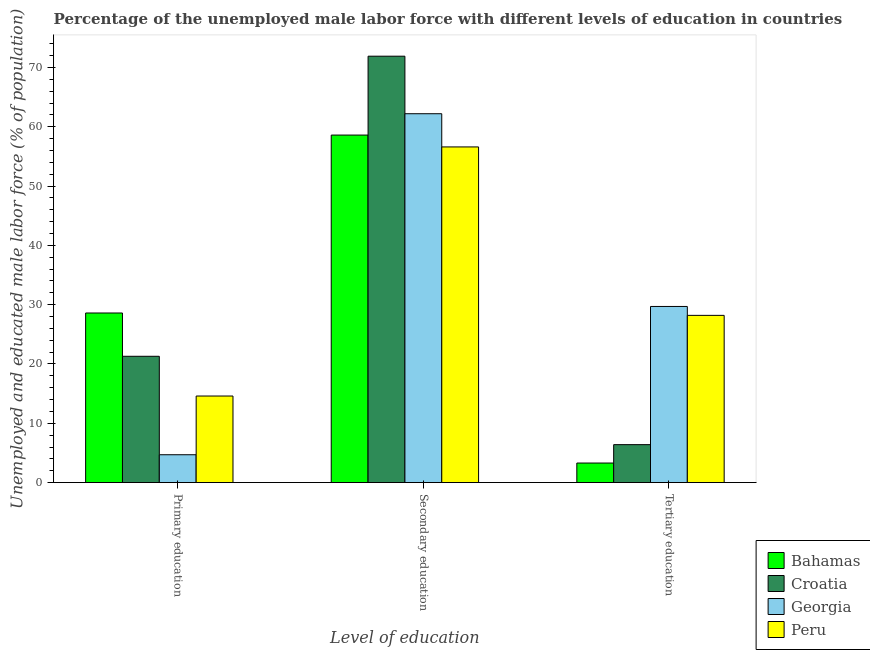How many different coloured bars are there?
Make the answer very short. 4. Are the number of bars per tick equal to the number of legend labels?
Make the answer very short. Yes. Are the number of bars on each tick of the X-axis equal?
Make the answer very short. Yes. How many bars are there on the 1st tick from the right?
Your response must be concise. 4. What is the label of the 2nd group of bars from the left?
Provide a short and direct response. Secondary education. What is the percentage of male labor force who received secondary education in Georgia?
Your answer should be compact. 62.2. Across all countries, what is the maximum percentage of male labor force who received tertiary education?
Provide a succinct answer. 29.7. Across all countries, what is the minimum percentage of male labor force who received secondary education?
Keep it short and to the point. 56.6. In which country was the percentage of male labor force who received secondary education maximum?
Offer a very short reply. Croatia. In which country was the percentage of male labor force who received secondary education minimum?
Ensure brevity in your answer.  Peru. What is the total percentage of male labor force who received secondary education in the graph?
Offer a terse response. 249.3. What is the difference between the percentage of male labor force who received tertiary education in Peru and that in Georgia?
Offer a terse response. -1.5. What is the difference between the percentage of male labor force who received tertiary education in Croatia and the percentage of male labor force who received primary education in Bahamas?
Your response must be concise. -22.2. What is the average percentage of male labor force who received tertiary education per country?
Keep it short and to the point. 16.9. What is the difference between the percentage of male labor force who received secondary education and percentage of male labor force who received tertiary education in Croatia?
Provide a succinct answer. 65.5. What is the ratio of the percentage of male labor force who received primary education in Peru to that in Georgia?
Your answer should be very brief. 3.11. Is the percentage of male labor force who received tertiary education in Bahamas less than that in Peru?
Your answer should be compact. Yes. Is the difference between the percentage of male labor force who received primary education in Peru and Bahamas greater than the difference between the percentage of male labor force who received tertiary education in Peru and Bahamas?
Give a very brief answer. No. What is the difference between the highest and the lowest percentage of male labor force who received secondary education?
Give a very brief answer. 15.3. What does the 4th bar from the right in Tertiary education represents?
Keep it short and to the point. Bahamas. Is it the case that in every country, the sum of the percentage of male labor force who received primary education and percentage of male labor force who received secondary education is greater than the percentage of male labor force who received tertiary education?
Provide a succinct answer. Yes. What is the difference between two consecutive major ticks on the Y-axis?
Make the answer very short. 10. Does the graph contain any zero values?
Ensure brevity in your answer.  No. Does the graph contain grids?
Offer a very short reply. No. How many legend labels are there?
Offer a terse response. 4. What is the title of the graph?
Provide a short and direct response. Percentage of the unemployed male labor force with different levels of education in countries. What is the label or title of the X-axis?
Your answer should be compact. Level of education. What is the label or title of the Y-axis?
Your response must be concise. Unemployed and educated male labor force (% of population). What is the Unemployed and educated male labor force (% of population) of Bahamas in Primary education?
Your response must be concise. 28.6. What is the Unemployed and educated male labor force (% of population) of Croatia in Primary education?
Provide a short and direct response. 21.3. What is the Unemployed and educated male labor force (% of population) in Georgia in Primary education?
Provide a succinct answer. 4.7. What is the Unemployed and educated male labor force (% of population) in Peru in Primary education?
Offer a terse response. 14.6. What is the Unemployed and educated male labor force (% of population) of Bahamas in Secondary education?
Your answer should be compact. 58.6. What is the Unemployed and educated male labor force (% of population) of Croatia in Secondary education?
Ensure brevity in your answer.  71.9. What is the Unemployed and educated male labor force (% of population) of Georgia in Secondary education?
Keep it short and to the point. 62.2. What is the Unemployed and educated male labor force (% of population) in Peru in Secondary education?
Keep it short and to the point. 56.6. What is the Unemployed and educated male labor force (% of population) of Bahamas in Tertiary education?
Provide a short and direct response. 3.3. What is the Unemployed and educated male labor force (% of population) in Croatia in Tertiary education?
Keep it short and to the point. 6.4. What is the Unemployed and educated male labor force (% of population) of Georgia in Tertiary education?
Your answer should be very brief. 29.7. What is the Unemployed and educated male labor force (% of population) in Peru in Tertiary education?
Make the answer very short. 28.2. Across all Level of education, what is the maximum Unemployed and educated male labor force (% of population) in Bahamas?
Provide a succinct answer. 58.6. Across all Level of education, what is the maximum Unemployed and educated male labor force (% of population) in Croatia?
Your response must be concise. 71.9. Across all Level of education, what is the maximum Unemployed and educated male labor force (% of population) of Georgia?
Your answer should be very brief. 62.2. Across all Level of education, what is the maximum Unemployed and educated male labor force (% of population) in Peru?
Make the answer very short. 56.6. Across all Level of education, what is the minimum Unemployed and educated male labor force (% of population) in Bahamas?
Your answer should be compact. 3.3. Across all Level of education, what is the minimum Unemployed and educated male labor force (% of population) of Croatia?
Offer a very short reply. 6.4. Across all Level of education, what is the minimum Unemployed and educated male labor force (% of population) in Georgia?
Make the answer very short. 4.7. Across all Level of education, what is the minimum Unemployed and educated male labor force (% of population) in Peru?
Your answer should be very brief. 14.6. What is the total Unemployed and educated male labor force (% of population) of Bahamas in the graph?
Your response must be concise. 90.5. What is the total Unemployed and educated male labor force (% of population) in Croatia in the graph?
Your answer should be compact. 99.6. What is the total Unemployed and educated male labor force (% of population) of Georgia in the graph?
Provide a succinct answer. 96.6. What is the total Unemployed and educated male labor force (% of population) in Peru in the graph?
Your answer should be compact. 99.4. What is the difference between the Unemployed and educated male labor force (% of population) of Croatia in Primary education and that in Secondary education?
Provide a short and direct response. -50.6. What is the difference between the Unemployed and educated male labor force (% of population) in Georgia in Primary education and that in Secondary education?
Offer a terse response. -57.5. What is the difference between the Unemployed and educated male labor force (% of population) of Peru in Primary education and that in Secondary education?
Give a very brief answer. -42. What is the difference between the Unemployed and educated male labor force (% of population) of Bahamas in Primary education and that in Tertiary education?
Offer a terse response. 25.3. What is the difference between the Unemployed and educated male labor force (% of population) in Georgia in Primary education and that in Tertiary education?
Offer a very short reply. -25. What is the difference between the Unemployed and educated male labor force (% of population) in Bahamas in Secondary education and that in Tertiary education?
Provide a succinct answer. 55.3. What is the difference between the Unemployed and educated male labor force (% of population) of Croatia in Secondary education and that in Tertiary education?
Your response must be concise. 65.5. What is the difference between the Unemployed and educated male labor force (% of population) of Georgia in Secondary education and that in Tertiary education?
Ensure brevity in your answer.  32.5. What is the difference between the Unemployed and educated male labor force (% of population) in Peru in Secondary education and that in Tertiary education?
Your response must be concise. 28.4. What is the difference between the Unemployed and educated male labor force (% of population) in Bahamas in Primary education and the Unemployed and educated male labor force (% of population) in Croatia in Secondary education?
Your answer should be compact. -43.3. What is the difference between the Unemployed and educated male labor force (% of population) in Bahamas in Primary education and the Unemployed and educated male labor force (% of population) in Georgia in Secondary education?
Your answer should be compact. -33.6. What is the difference between the Unemployed and educated male labor force (% of population) of Bahamas in Primary education and the Unemployed and educated male labor force (% of population) of Peru in Secondary education?
Your response must be concise. -28. What is the difference between the Unemployed and educated male labor force (% of population) of Croatia in Primary education and the Unemployed and educated male labor force (% of population) of Georgia in Secondary education?
Keep it short and to the point. -40.9. What is the difference between the Unemployed and educated male labor force (% of population) in Croatia in Primary education and the Unemployed and educated male labor force (% of population) in Peru in Secondary education?
Offer a very short reply. -35.3. What is the difference between the Unemployed and educated male labor force (% of population) of Georgia in Primary education and the Unemployed and educated male labor force (% of population) of Peru in Secondary education?
Your answer should be very brief. -51.9. What is the difference between the Unemployed and educated male labor force (% of population) of Bahamas in Primary education and the Unemployed and educated male labor force (% of population) of Croatia in Tertiary education?
Keep it short and to the point. 22.2. What is the difference between the Unemployed and educated male labor force (% of population) in Bahamas in Primary education and the Unemployed and educated male labor force (% of population) in Peru in Tertiary education?
Offer a terse response. 0.4. What is the difference between the Unemployed and educated male labor force (% of population) of Croatia in Primary education and the Unemployed and educated male labor force (% of population) of Peru in Tertiary education?
Your answer should be very brief. -6.9. What is the difference between the Unemployed and educated male labor force (% of population) of Georgia in Primary education and the Unemployed and educated male labor force (% of population) of Peru in Tertiary education?
Provide a short and direct response. -23.5. What is the difference between the Unemployed and educated male labor force (% of population) in Bahamas in Secondary education and the Unemployed and educated male labor force (% of population) in Croatia in Tertiary education?
Provide a succinct answer. 52.2. What is the difference between the Unemployed and educated male labor force (% of population) in Bahamas in Secondary education and the Unemployed and educated male labor force (% of population) in Georgia in Tertiary education?
Make the answer very short. 28.9. What is the difference between the Unemployed and educated male labor force (% of population) of Bahamas in Secondary education and the Unemployed and educated male labor force (% of population) of Peru in Tertiary education?
Provide a short and direct response. 30.4. What is the difference between the Unemployed and educated male labor force (% of population) in Croatia in Secondary education and the Unemployed and educated male labor force (% of population) in Georgia in Tertiary education?
Ensure brevity in your answer.  42.2. What is the difference between the Unemployed and educated male labor force (% of population) of Croatia in Secondary education and the Unemployed and educated male labor force (% of population) of Peru in Tertiary education?
Offer a very short reply. 43.7. What is the average Unemployed and educated male labor force (% of population) of Bahamas per Level of education?
Your response must be concise. 30.17. What is the average Unemployed and educated male labor force (% of population) of Croatia per Level of education?
Keep it short and to the point. 33.2. What is the average Unemployed and educated male labor force (% of population) in Georgia per Level of education?
Provide a short and direct response. 32.2. What is the average Unemployed and educated male labor force (% of population) in Peru per Level of education?
Your answer should be very brief. 33.13. What is the difference between the Unemployed and educated male labor force (% of population) of Bahamas and Unemployed and educated male labor force (% of population) of Croatia in Primary education?
Your answer should be very brief. 7.3. What is the difference between the Unemployed and educated male labor force (% of population) of Bahamas and Unemployed and educated male labor force (% of population) of Georgia in Primary education?
Provide a short and direct response. 23.9. What is the difference between the Unemployed and educated male labor force (% of population) in Georgia and Unemployed and educated male labor force (% of population) in Peru in Primary education?
Make the answer very short. -9.9. What is the difference between the Unemployed and educated male labor force (% of population) of Bahamas and Unemployed and educated male labor force (% of population) of Georgia in Secondary education?
Provide a succinct answer. -3.6. What is the difference between the Unemployed and educated male labor force (% of population) in Croatia and Unemployed and educated male labor force (% of population) in Georgia in Secondary education?
Offer a terse response. 9.7. What is the difference between the Unemployed and educated male labor force (% of population) in Croatia and Unemployed and educated male labor force (% of population) in Peru in Secondary education?
Provide a short and direct response. 15.3. What is the difference between the Unemployed and educated male labor force (% of population) of Bahamas and Unemployed and educated male labor force (% of population) of Georgia in Tertiary education?
Your response must be concise. -26.4. What is the difference between the Unemployed and educated male labor force (% of population) of Bahamas and Unemployed and educated male labor force (% of population) of Peru in Tertiary education?
Offer a very short reply. -24.9. What is the difference between the Unemployed and educated male labor force (% of population) of Croatia and Unemployed and educated male labor force (% of population) of Georgia in Tertiary education?
Provide a succinct answer. -23.3. What is the difference between the Unemployed and educated male labor force (% of population) in Croatia and Unemployed and educated male labor force (% of population) in Peru in Tertiary education?
Your answer should be compact. -21.8. What is the difference between the Unemployed and educated male labor force (% of population) in Georgia and Unemployed and educated male labor force (% of population) in Peru in Tertiary education?
Give a very brief answer. 1.5. What is the ratio of the Unemployed and educated male labor force (% of population) of Bahamas in Primary education to that in Secondary education?
Keep it short and to the point. 0.49. What is the ratio of the Unemployed and educated male labor force (% of population) of Croatia in Primary education to that in Secondary education?
Give a very brief answer. 0.3. What is the ratio of the Unemployed and educated male labor force (% of population) in Georgia in Primary education to that in Secondary education?
Your answer should be very brief. 0.08. What is the ratio of the Unemployed and educated male labor force (% of population) of Peru in Primary education to that in Secondary education?
Make the answer very short. 0.26. What is the ratio of the Unemployed and educated male labor force (% of population) in Bahamas in Primary education to that in Tertiary education?
Provide a succinct answer. 8.67. What is the ratio of the Unemployed and educated male labor force (% of population) of Croatia in Primary education to that in Tertiary education?
Make the answer very short. 3.33. What is the ratio of the Unemployed and educated male labor force (% of population) of Georgia in Primary education to that in Tertiary education?
Offer a terse response. 0.16. What is the ratio of the Unemployed and educated male labor force (% of population) in Peru in Primary education to that in Tertiary education?
Provide a short and direct response. 0.52. What is the ratio of the Unemployed and educated male labor force (% of population) of Bahamas in Secondary education to that in Tertiary education?
Keep it short and to the point. 17.76. What is the ratio of the Unemployed and educated male labor force (% of population) in Croatia in Secondary education to that in Tertiary education?
Your response must be concise. 11.23. What is the ratio of the Unemployed and educated male labor force (% of population) in Georgia in Secondary education to that in Tertiary education?
Your response must be concise. 2.09. What is the ratio of the Unemployed and educated male labor force (% of population) in Peru in Secondary education to that in Tertiary education?
Provide a succinct answer. 2.01. What is the difference between the highest and the second highest Unemployed and educated male labor force (% of population) of Croatia?
Provide a succinct answer. 50.6. What is the difference between the highest and the second highest Unemployed and educated male labor force (% of population) of Georgia?
Provide a short and direct response. 32.5. What is the difference between the highest and the second highest Unemployed and educated male labor force (% of population) of Peru?
Offer a terse response. 28.4. What is the difference between the highest and the lowest Unemployed and educated male labor force (% of population) of Bahamas?
Your answer should be very brief. 55.3. What is the difference between the highest and the lowest Unemployed and educated male labor force (% of population) of Croatia?
Your response must be concise. 65.5. What is the difference between the highest and the lowest Unemployed and educated male labor force (% of population) in Georgia?
Ensure brevity in your answer.  57.5. What is the difference between the highest and the lowest Unemployed and educated male labor force (% of population) in Peru?
Provide a short and direct response. 42. 